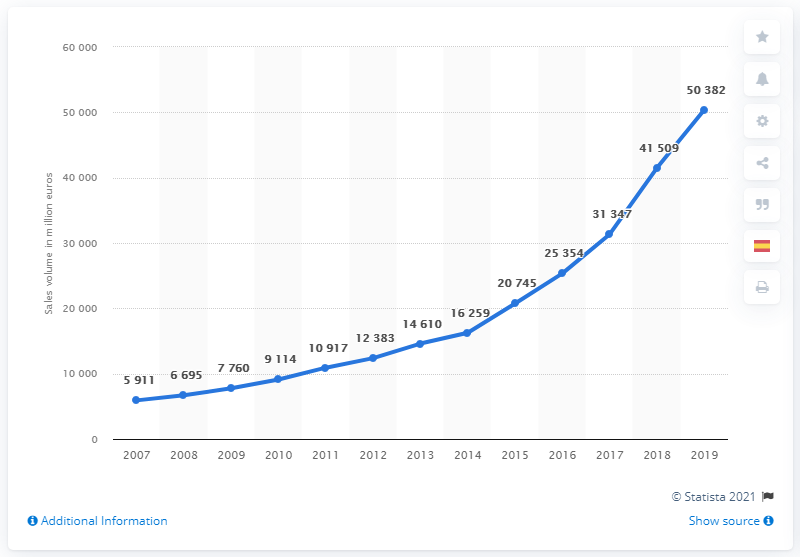Highlight a few significant elements in this photo. In 2019, the value of online shopping in Spain was approximately 50,382. The volume increases. The difference between 2015 and 2019 is 2019 is a year that comes after 2015. 